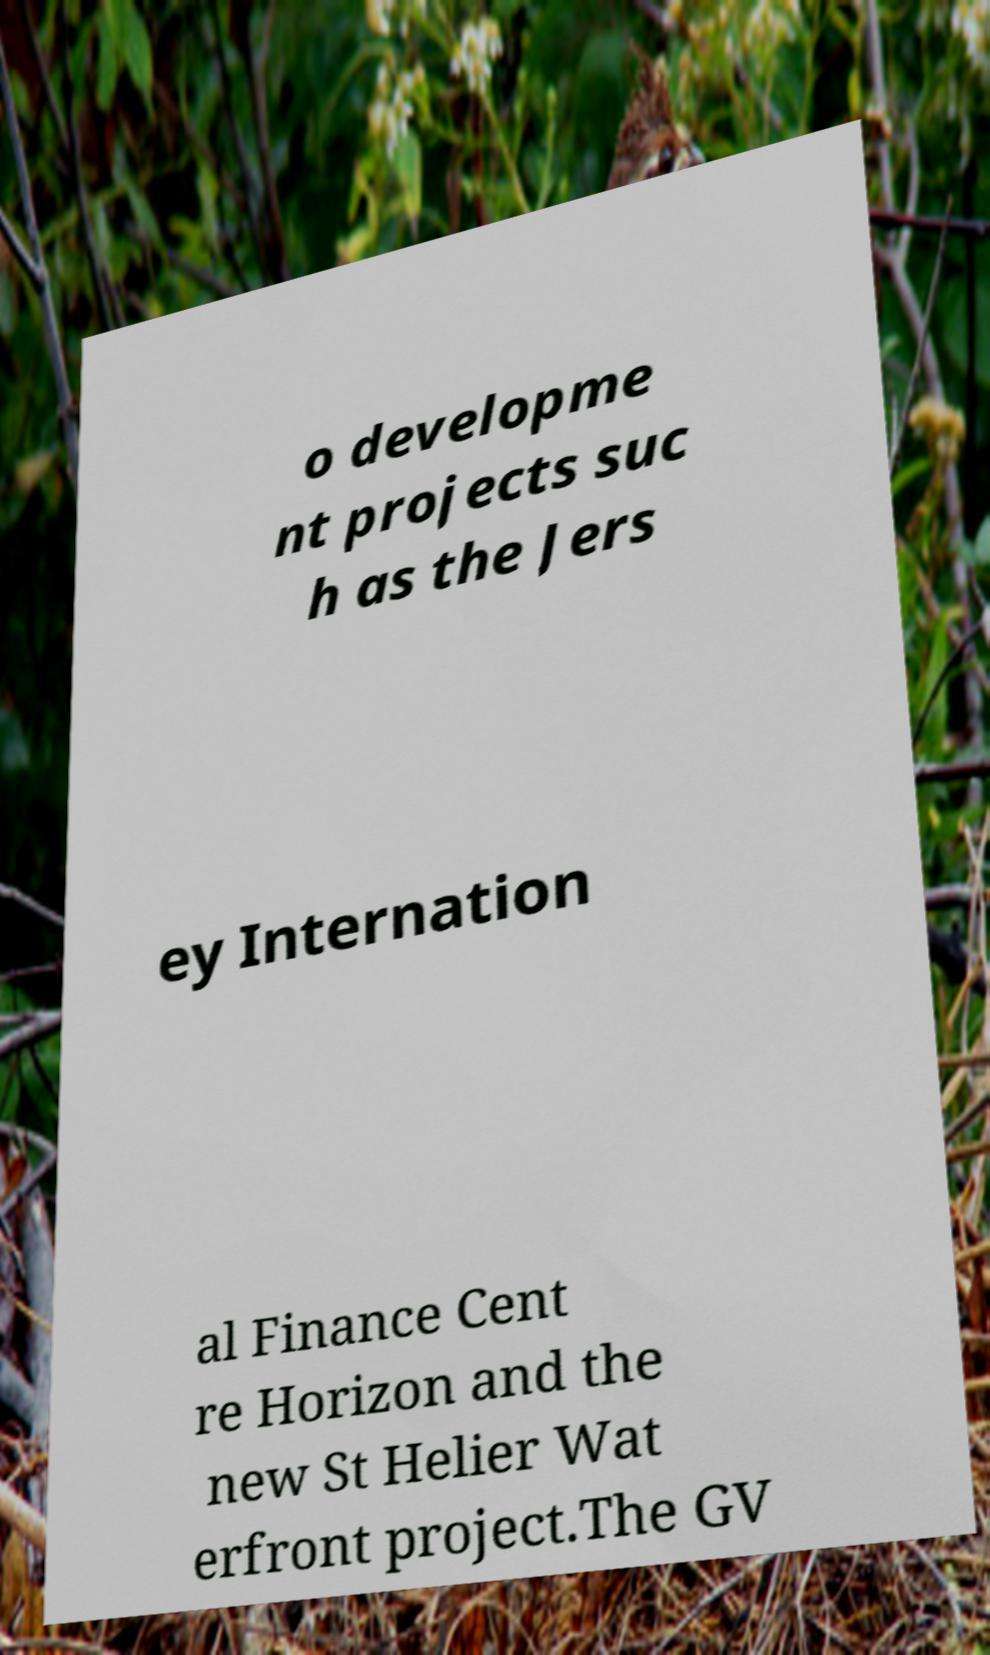Could you extract and type out the text from this image? o developme nt projects suc h as the Jers ey Internation al Finance Cent re Horizon and the new St Helier Wat erfront project.The GV 